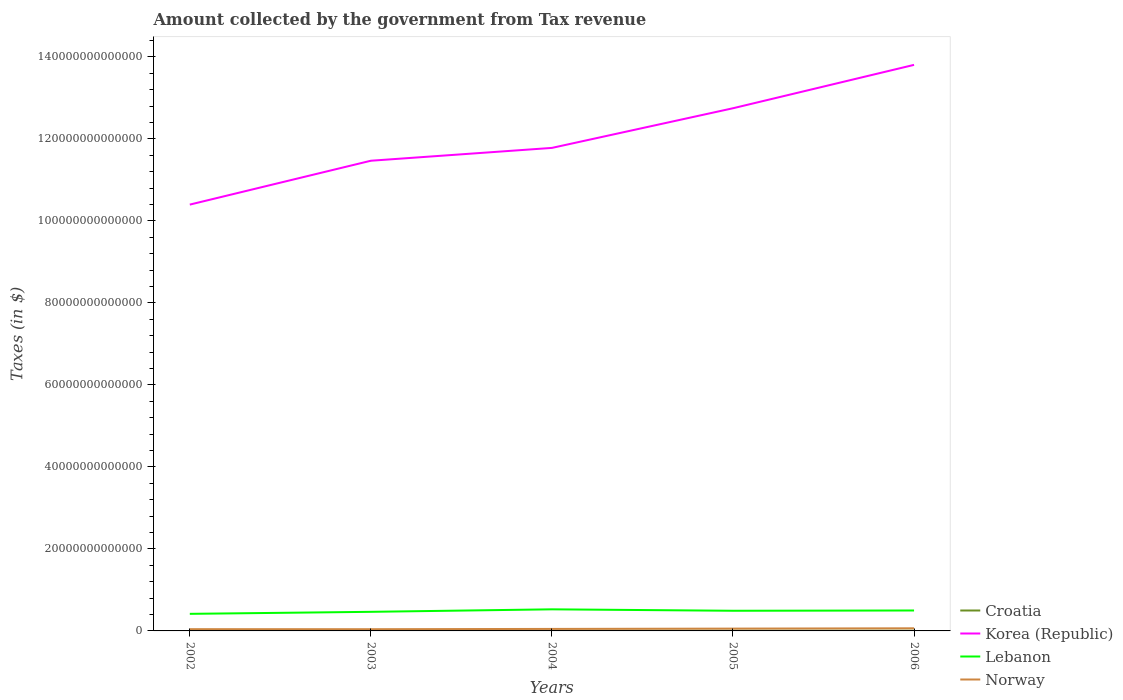Across all years, what is the maximum amount collected by the government from tax revenue in Lebanon?
Keep it short and to the point. 4.17e+12. In which year was the amount collected by the government from tax revenue in Croatia maximum?
Provide a succinct answer. 2002. What is the total amount collected by the government from tax revenue in Korea (Republic) in the graph?
Provide a short and direct response. -1.38e+13. What is the difference between the highest and the second highest amount collected by the government from tax revenue in Lebanon?
Your answer should be very brief. 1.10e+12. Is the amount collected by the government from tax revenue in Lebanon strictly greater than the amount collected by the government from tax revenue in Croatia over the years?
Offer a very short reply. No. How many years are there in the graph?
Your answer should be very brief. 5. What is the difference between two consecutive major ticks on the Y-axis?
Provide a short and direct response. 2.00e+13. Are the values on the major ticks of Y-axis written in scientific E-notation?
Your answer should be very brief. No. Does the graph contain grids?
Make the answer very short. No. Where does the legend appear in the graph?
Offer a terse response. Bottom right. How many legend labels are there?
Offer a terse response. 4. How are the legend labels stacked?
Provide a succinct answer. Vertical. What is the title of the graph?
Provide a succinct answer. Amount collected by the government from Tax revenue. What is the label or title of the Y-axis?
Keep it short and to the point. Taxes (in $). What is the Taxes (in $) in Croatia in 2002?
Your response must be concise. 4.52e+1. What is the Taxes (in $) in Korea (Republic) in 2002?
Provide a short and direct response. 1.04e+14. What is the Taxes (in $) of Lebanon in 2002?
Ensure brevity in your answer.  4.17e+12. What is the Taxes (in $) in Norway in 2002?
Ensure brevity in your answer.  4.28e+11. What is the Taxes (in $) of Croatia in 2003?
Your answer should be very brief. 4.79e+1. What is the Taxes (in $) in Korea (Republic) in 2003?
Offer a terse response. 1.15e+14. What is the Taxes (in $) in Lebanon in 2003?
Offer a terse response. 4.66e+12. What is the Taxes (in $) in Norway in 2003?
Your response must be concise. 4.19e+11. What is the Taxes (in $) of Croatia in 2004?
Ensure brevity in your answer.  4.98e+1. What is the Taxes (in $) of Korea (Republic) in 2004?
Give a very brief answer. 1.18e+14. What is the Taxes (in $) of Lebanon in 2004?
Your response must be concise. 5.27e+12. What is the Taxes (in $) of Norway in 2004?
Your answer should be compact. 4.87e+11. What is the Taxes (in $) in Croatia in 2005?
Your answer should be compact. 5.34e+1. What is the Taxes (in $) of Korea (Republic) in 2005?
Provide a succinct answer. 1.27e+14. What is the Taxes (in $) in Lebanon in 2005?
Ensure brevity in your answer.  4.92e+12. What is the Taxes (in $) in Norway in 2005?
Provide a short and direct response. 5.63e+11. What is the Taxes (in $) of Croatia in 2006?
Your response must be concise. 5.85e+1. What is the Taxes (in $) in Korea (Republic) in 2006?
Keep it short and to the point. 1.38e+14. What is the Taxes (in $) of Lebanon in 2006?
Ensure brevity in your answer.  4.98e+12. What is the Taxes (in $) of Norway in 2006?
Provide a succinct answer. 6.41e+11. Across all years, what is the maximum Taxes (in $) of Croatia?
Give a very brief answer. 5.85e+1. Across all years, what is the maximum Taxes (in $) of Korea (Republic)?
Ensure brevity in your answer.  1.38e+14. Across all years, what is the maximum Taxes (in $) of Lebanon?
Provide a short and direct response. 5.27e+12. Across all years, what is the maximum Taxes (in $) in Norway?
Offer a terse response. 6.41e+11. Across all years, what is the minimum Taxes (in $) of Croatia?
Offer a terse response. 4.52e+1. Across all years, what is the minimum Taxes (in $) in Korea (Republic)?
Give a very brief answer. 1.04e+14. Across all years, what is the minimum Taxes (in $) of Lebanon?
Your response must be concise. 4.17e+12. Across all years, what is the minimum Taxes (in $) of Norway?
Give a very brief answer. 4.19e+11. What is the total Taxes (in $) of Croatia in the graph?
Give a very brief answer. 2.55e+11. What is the total Taxes (in $) of Korea (Republic) in the graph?
Make the answer very short. 6.02e+14. What is the total Taxes (in $) in Lebanon in the graph?
Give a very brief answer. 2.40e+13. What is the total Taxes (in $) in Norway in the graph?
Your answer should be compact. 2.54e+12. What is the difference between the Taxes (in $) of Croatia in 2002 and that in 2003?
Keep it short and to the point. -2.74e+09. What is the difference between the Taxes (in $) of Korea (Republic) in 2002 and that in 2003?
Provide a succinct answer. -1.07e+13. What is the difference between the Taxes (in $) in Lebanon in 2002 and that in 2003?
Make the answer very short. -4.89e+11. What is the difference between the Taxes (in $) of Norway in 2002 and that in 2003?
Offer a very short reply. 9.12e+09. What is the difference between the Taxes (in $) in Croatia in 2002 and that in 2004?
Give a very brief answer. -4.66e+09. What is the difference between the Taxes (in $) of Korea (Republic) in 2002 and that in 2004?
Keep it short and to the point. -1.38e+13. What is the difference between the Taxes (in $) of Lebanon in 2002 and that in 2004?
Offer a terse response. -1.10e+12. What is the difference between the Taxes (in $) in Norway in 2002 and that in 2004?
Give a very brief answer. -5.94e+1. What is the difference between the Taxes (in $) in Croatia in 2002 and that in 2005?
Give a very brief answer. -8.28e+09. What is the difference between the Taxes (in $) of Korea (Republic) in 2002 and that in 2005?
Offer a terse response. -2.35e+13. What is the difference between the Taxes (in $) in Lebanon in 2002 and that in 2005?
Make the answer very short. -7.49e+11. What is the difference between the Taxes (in $) in Norway in 2002 and that in 2005?
Your answer should be very brief. -1.35e+11. What is the difference between the Taxes (in $) in Croatia in 2002 and that in 2006?
Provide a short and direct response. -1.33e+1. What is the difference between the Taxes (in $) of Korea (Republic) in 2002 and that in 2006?
Give a very brief answer. -3.41e+13. What is the difference between the Taxes (in $) of Lebanon in 2002 and that in 2006?
Keep it short and to the point. -8.16e+11. What is the difference between the Taxes (in $) of Norway in 2002 and that in 2006?
Give a very brief answer. -2.13e+11. What is the difference between the Taxes (in $) in Croatia in 2003 and that in 2004?
Keep it short and to the point. -1.92e+09. What is the difference between the Taxes (in $) in Korea (Republic) in 2003 and that in 2004?
Your answer should be compact. -3.13e+12. What is the difference between the Taxes (in $) in Lebanon in 2003 and that in 2004?
Keep it short and to the point. -6.11e+11. What is the difference between the Taxes (in $) of Norway in 2003 and that in 2004?
Give a very brief answer. -6.85e+1. What is the difference between the Taxes (in $) of Croatia in 2003 and that in 2005?
Keep it short and to the point. -5.54e+09. What is the difference between the Taxes (in $) in Korea (Republic) in 2003 and that in 2005?
Your answer should be compact. -1.28e+13. What is the difference between the Taxes (in $) of Lebanon in 2003 and that in 2005?
Ensure brevity in your answer.  -2.60e+11. What is the difference between the Taxes (in $) in Norway in 2003 and that in 2005?
Offer a terse response. -1.44e+11. What is the difference between the Taxes (in $) of Croatia in 2003 and that in 2006?
Make the answer very short. -1.06e+1. What is the difference between the Taxes (in $) in Korea (Republic) in 2003 and that in 2006?
Give a very brief answer. -2.34e+13. What is the difference between the Taxes (in $) of Lebanon in 2003 and that in 2006?
Keep it short and to the point. -3.27e+11. What is the difference between the Taxes (in $) of Norway in 2003 and that in 2006?
Give a very brief answer. -2.22e+11. What is the difference between the Taxes (in $) of Croatia in 2004 and that in 2005?
Provide a short and direct response. -3.62e+09. What is the difference between the Taxes (in $) of Korea (Republic) in 2004 and that in 2005?
Offer a very short reply. -9.67e+12. What is the difference between the Taxes (in $) of Lebanon in 2004 and that in 2005?
Your answer should be very brief. 3.50e+11. What is the difference between the Taxes (in $) of Norway in 2004 and that in 2005?
Your answer should be compact. -7.53e+1. What is the difference between the Taxes (in $) in Croatia in 2004 and that in 2006?
Keep it short and to the point. -8.64e+09. What is the difference between the Taxes (in $) of Korea (Republic) in 2004 and that in 2006?
Keep it short and to the point. -2.02e+13. What is the difference between the Taxes (in $) of Lebanon in 2004 and that in 2006?
Your answer should be compact. 2.83e+11. What is the difference between the Taxes (in $) in Norway in 2004 and that in 2006?
Your answer should be compact. -1.54e+11. What is the difference between the Taxes (in $) in Croatia in 2005 and that in 2006?
Offer a very short reply. -5.02e+09. What is the difference between the Taxes (in $) of Korea (Republic) in 2005 and that in 2006?
Offer a terse response. -1.06e+13. What is the difference between the Taxes (in $) of Lebanon in 2005 and that in 2006?
Ensure brevity in your answer.  -6.71e+1. What is the difference between the Taxes (in $) in Norway in 2005 and that in 2006?
Offer a terse response. -7.84e+1. What is the difference between the Taxes (in $) of Croatia in 2002 and the Taxes (in $) of Korea (Republic) in 2003?
Give a very brief answer. -1.15e+14. What is the difference between the Taxes (in $) in Croatia in 2002 and the Taxes (in $) in Lebanon in 2003?
Keep it short and to the point. -4.61e+12. What is the difference between the Taxes (in $) of Croatia in 2002 and the Taxes (in $) of Norway in 2003?
Offer a very short reply. -3.74e+11. What is the difference between the Taxes (in $) of Korea (Republic) in 2002 and the Taxes (in $) of Lebanon in 2003?
Provide a short and direct response. 9.93e+13. What is the difference between the Taxes (in $) in Korea (Republic) in 2002 and the Taxes (in $) in Norway in 2003?
Your response must be concise. 1.04e+14. What is the difference between the Taxes (in $) in Lebanon in 2002 and the Taxes (in $) in Norway in 2003?
Give a very brief answer. 3.75e+12. What is the difference between the Taxes (in $) in Croatia in 2002 and the Taxes (in $) in Korea (Republic) in 2004?
Keep it short and to the point. -1.18e+14. What is the difference between the Taxes (in $) in Croatia in 2002 and the Taxes (in $) in Lebanon in 2004?
Ensure brevity in your answer.  -5.22e+12. What is the difference between the Taxes (in $) in Croatia in 2002 and the Taxes (in $) in Norway in 2004?
Offer a very short reply. -4.42e+11. What is the difference between the Taxes (in $) in Korea (Republic) in 2002 and the Taxes (in $) in Lebanon in 2004?
Offer a very short reply. 9.87e+13. What is the difference between the Taxes (in $) of Korea (Republic) in 2002 and the Taxes (in $) of Norway in 2004?
Keep it short and to the point. 1.03e+14. What is the difference between the Taxes (in $) of Lebanon in 2002 and the Taxes (in $) of Norway in 2004?
Keep it short and to the point. 3.68e+12. What is the difference between the Taxes (in $) of Croatia in 2002 and the Taxes (in $) of Korea (Republic) in 2005?
Provide a succinct answer. -1.27e+14. What is the difference between the Taxes (in $) in Croatia in 2002 and the Taxes (in $) in Lebanon in 2005?
Offer a terse response. -4.87e+12. What is the difference between the Taxes (in $) of Croatia in 2002 and the Taxes (in $) of Norway in 2005?
Offer a terse response. -5.18e+11. What is the difference between the Taxes (in $) in Korea (Republic) in 2002 and the Taxes (in $) in Lebanon in 2005?
Ensure brevity in your answer.  9.91e+13. What is the difference between the Taxes (in $) of Korea (Republic) in 2002 and the Taxes (in $) of Norway in 2005?
Your answer should be very brief. 1.03e+14. What is the difference between the Taxes (in $) in Lebanon in 2002 and the Taxes (in $) in Norway in 2005?
Your response must be concise. 3.60e+12. What is the difference between the Taxes (in $) in Croatia in 2002 and the Taxes (in $) in Korea (Republic) in 2006?
Offer a terse response. -1.38e+14. What is the difference between the Taxes (in $) of Croatia in 2002 and the Taxes (in $) of Lebanon in 2006?
Offer a very short reply. -4.94e+12. What is the difference between the Taxes (in $) in Croatia in 2002 and the Taxes (in $) in Norway in 2006?
Your response must be concise. -5.96e+11. What is the difference between the Taxes (in $) in Korea (Republic) in 2002 and the Taxes (in $) in Lebanon in 2006?
Ensure brevity in your answer.  9.90e+13. What is the difference between the Taxes (in $) of Korea (Republic) in 2002 and the Taxes (in $) of Norway in 2006?
Make the answer very short. 1.03e+14. What is the difference between the Taxes (in $) in Lebanon in 2002 and the Taxes (in $) in Norway in 2006?
Offer a terse response. 3.53e+12. What is the difference between the Taxes (in $) of Croatia in 2003 and the Taxes (in $) of Korea (Republic) in 2004?
Your response must be concise. -1.18e+14. What is the difference between the Taxes (in $) in Croatia in 2003 and the Taxes (in $) in Lebanon in 2004?
Keep it short and to the point. -5.22e+12. What is the difference between the Taxes (in $) in Croatia in 2003 and the Taxes (in $) in Norway in 2004?
Provide a succinct answer. -4.39e+11. What is the difference between the Taxes (in $) in Korea (Republic) in 2003 and the Taxes (in $) in Lebanon in 2004?
Ensure brevity in your answer.  1.09e+14. What is the difference between the Taxes (in $) in Korea (Republic) in 2003 and the Taxes (in $) in Norway in 2004?
Provide a succinct answer. 1.14e+14. What is the difference between the Taxes (in $) in Lebanon in 2003 and the Taxes (in $) in Norway in 2004?
Your answer should be compact. 4.17e+12. What is the difference between the Taxes (in $) of Croatia in 2003 and the Taxes (in $) of Korea (Republic) in 2005?
Your response must be concise. -1.27e+14. What is the difference between the Taxes (in $) of Croatia in 2003 and the Taxes (in $) of Lebanon in 2005?
Ensure brevity in your answer.  -4.87e+12. What is the difference between the Taxes (in $) in Croatia in 2003 and the Taxes (in $) in Norway in 2005?
Your answer should be very brief. -5.15e+11. What is the difference between the Taxes (in $) of Korea (Republic) in 2003 and the Taxes (in $) of Lebanon in 2005?
Provide a succinct answer. 1.10e+14. What is the difference between the Taxes (in $) in Korea (Republic) in 2003 and the Taxes (in $) in Norway in 2005?
Provide a short and direct response. 1.14e+14. What is the difference between the Taxes (in $) in Lebanon in 2003 and the Taxes (in $) in Norway in 2005?
Provide a succinct answer. 4.09e+12. What is the difference between the Taxes (in $) of Croatia in 2003 and the Taxes (in $) of Korea (Republic) in 2006?
Your answer should be compact. -1.38e+14. What is the difference between the Taxes (in $) of Croatia in 2003 and the Taxes (in $) of Lebanon in 2006?
Provide a short and direct response. -4.93e+12. What is the difference between the Taxes (in $) in Croatia in 2003 and the Taxes (in $) in Norway in 2006?
Your answer should be very brief. -5.93e+11. What is the difference between the Taxes (in $) in Korea (Republic) in 2003 and the Taxes (in $) in Lebanon in 2006?
Give a very brief answer. 1.10e+14. What is the difference between the Taxes (in $) of Korea (Republic) in 2003 and the Taxes (in $) of Norway in 2006?
Offer a terse response. 1.14e+14. What is the difference between the Taxes (in $) in Lebanon in 2003 and the Taxes (in $) in Norway in 2006?
Provide a succinct answer. 4.01e+12. What is the difference between the Taxes (in $) in Croatia in 2004 and the Taxes (in $) in Korea (Republic) in 2005?
Provide a short and direct response. -1.27e+14. What is the difference between the Taxes (in $) in Croatia in 2004 and the Taxes (in $) in Lebanon in 2005?
Keep it short and to the point. -4.87e+12. What is the difference between the Taxes (in $) in Croatia in 2004 and the Taxes (in $) in Norway in 2005?
Your answer should be compact. -5.13e+11. What is the difference between the Taxes (in $) in Korea (Republic) in 2004 and the Taxes (in $) in Lebanon in 2005?
Provide a succinct answer. 1.13e+14. What is the difference between the Taxes (in $) of Korea (Republic) in 2004 and the Taxes (in $) of Norway in 2005?
Make the answer very short. 1.17e+14. What is the difference between the Taxes (in $) of Lebanon in 2004 and the Taxes (in $) of Norway in 2005?
Offer a very short reply. 4.70e+12. What is the difference between the Taxes (in $) of Croatia in 2004 and the Taxes (in $) of Korea (Republic) in 2006?
Your answer should be very brief. -1.38e+14. What is the difference between the Taxes (in $) of Croatia in 2004 and the Taxes (in $) of Lebanon in 2006?
Your answer should be very brief. -4.93e+12. What is the difference between the Taxes (in $) of Croatia in 2004 and the Taxes (in $) of Norway in 2006?
Provide a short and direct response. -5.91e+11. What is the difference between the Taxes (in $) of Korea (Republic) in 2004 and the Taxes (in $) of Lebanon in 2006?
Offer a very short reply. 1.13e+14. What is the difference between the Taxes (in $) of Korea (Republic) in 2004 and the Taxes (in $) of Norway in 2006?
Your response must be concise. 1.17e+14. What is the difference between the Taxes (in $) in Lebanon in 2004 and the Taxes (in $) in Norway in 2006?
Give a very brief answer. 4.62e+12. What is the difference between the Taxes (in $) in Croatia in 2005 and the Taxes (in $) in Korea (Republic) in 2006?
Provide a short and direct response. -1.38e+14. What is the difference between the Taxes (in $) of Croatia in 2005 and the Taxes (in $) of Lebanon in 2006?
Make the answer very short. -4.93e+12. What is the difference between the Taxes (in $) of Croatia in 2005 and the Taxes (in $) of Norway in 2006?
Your answer should be compact. -5.88e+11. What is the difference between the Taxes (in $) of Korea (Republic) in 2005 and the Taxes (in $) of Lebanon in 2006?
Your answer should be very brief. 1.22e+14. What is the difference between the Taxes (in $) of Korea (Republic) in 2005 and the Taxes (in $) of Norway in 2006?
Your answer should be very brief. 1.27e+14. What is the difference between the Taxes (in $) of Lebanon in 2005 and the Taxes (in $) of Norway in 2006?
Provide a short and direct response. 4.27e+12. What is the average Taxes (in $) in Croatia per year?
Ensure brevity in your answer.  5.10e+1. What is the average Taxes (in $) of Korea (Republic) per year?
Provide a succinct answer. 1.20e+14. What is the average Taxes (in $) in Lebanon per year?
Your answer should be compact. 4.80e+12. What is the average Taxes (in $) in Norway per year?
Offer a very short reply. 5.08e+11. In the year 2002, what is the difference between the Taxes (in $) of Croatia and Taxes (in $) of Korea (Republic)?
Your response must be concise. -1.04e+14. In the year 2002, what is the difference between the Taxes (in $) of Croatia and Taxes (in $) of Lebanon?
Keep it short and to the point. -4.12e+12. In the year 2002, what is the difference between the Taxes (in $) in Croatia and Taxes (in $) in Norway?
Ensure brevity in your answer.  -3.83e+11. In the year 2002, what is the difference between the Taxes (in $) in Korea (Republic) and Taxes (in $) in Lebanon?
Your answer should be compact. 9.98e+13. In the year 2002, what is the difference between the Taxes (in $) in Korea (Republic) and Taxes (in $) in Norway?
Your response must be concise. 1.04e+14. In the year 2002, what is the difference between the Taxes (in $) of Lebanon and Taxes (in $) of Norway?
Your response must be concise. 3.74e+12. In the year 2003, what is the difference between the Taxes (in $) of Croatia and Taxes (in $) of Korea (Republic)?
Offer a very short reply. -1.15e+14. In the year 2003, what is the difference between the Taxes (in $) in Croatia and Taxes (in $) in Lebanon?
Ensure brevity in your answer.  -4.61e+12. In the year 2003, what is the difference between the Taxes (in $) of Croatia and Taxes (in $) of Norway?
Offer a very short reply. -3.71e+11. In the year 2003, what is the difference between the Taxes (in $) of Korea (Republic) and Taxes (in $) of Lebanon?
Your response must be concise. 1.10e+14. In the year 2003, what is the difference between the Taxes (in $) in Korea (Republic) and Taxes (in $) in Norway?
Keep it short and to the point. 1.14e+14. In the year 2003, what is the difference between the Taxes (in $) of Lebanon and Taxes (in $) of Norway?
Your answer should be compact. 4.24e+12. In the year 2004, what is the difference between the Taxes (in $) in Croatia and Taxes (in $) in Korea (Republic)?
Ensure brevity in your answer.  -1.18e+14. In the year 2004, what is the difference between the Taxes (in $) of Croatia and Taxes (in $) of Lebanon?
Keep it short and to the point. -5.22e+12. In the year 2004, what is the difference between the Taxes (in $) in Croatia and Taxes (in $) in Norway?
Your answer should be very brief. -4.38e+11. In the year 2004, what is the difference between the Taxes (in $) in Korea (Republic) and Taxes (in $) in Lebanon?
Provide a succinct answer. 1.13e+14. In the year 2004, what is the difference between the Taxes (in $) in Korea (Republic) and Taxes (in $) in Norway?
Provide a succinct answer. 1.17e+14. In the year 2004, what is the difference between the Taxes (in $) in Lebanon and Taxes (in $) in Norway?
Offer a terse response. 4.78e+12. In the year 2005, what is the difference between the Taxes (in $) of Croatia and Taxes (in $) of Korea (Republic)?
Ensure brevity in your answer.  -1.27e+14. In the year 2005, what is the difference between the Taxes (in $) of Croatia and Taxes (in $) of Lebanon?
Your answer should be very brief. -4.86e+12. In the year 2005, what is the difference between the Taxes (in $) in Croatia and Taxes (in $) in Norway?
Keep it short and to the point. -5.09e+11. In the year 2005, what is the difference between the Taxes (in $) in Korea (Republic) and Taxes (in $) in Lebanon?
Offer a very short reply. 1.23e+14. In the year 2005, what is the difference between the Taxes (in $) of Korea (Republic) and Taxes (in $) of Norway?
Your answer should be compact. 1.27e+14. In the year 2005, what is the difference between the Taxes (in $) of Lebanon and Taxes (in $) of Norway?
Keep it short and to the point. 4.35e+12. In the year 2006, what is the difference between the Taxes (in $) of Croatia and Taxes (in $) of Korea (Republic)?
Your response must be concise. -1.38e+14. In the year 2006, what is the difference between the Taxes (in $) in Croatia and Taxes (in $) in Lebanon?
Give a very brief answer. -4.92e+12. In the year 2006, what is the difference between the Taxes (in $) in Croatia and Taxes (in $) in Norway?
Your answer should be compact. -5.83e+11. In the year 2006, what is the difference between the Taxes (in $) of Korea (Republic) and Taxes (in $) of Lebanon?
Ensure brevity in your answer.  1.33e+14. In the year 2006, what is the difference between the Taxes (in $) of Korea (Republic) and Taxes (in $) of Norway?
Provide a succinct answer. 1.37e+14. In the year 2006, what is the difference between the Taxes (in $) of Lebanon and Taxes (in $) of Norway?
Make the answer very short. 4.34e+12. What is the ratio of the Taxes (in $) in Croatia in 2002 to that in 2003?
Ensure brevity in your answer.  0.94. What is the ratio of the Taxes (in $) in Korea (Republic) in 2002 to that in 2003?
Ensure brevity in your answer.  0.91. What is the ratio of the Taxes (in $) of Lebanon in 2002 to that in 2003?
Your answer should be compact. 0.9. What is the ratio of the Taxes (in $) in Norway in 2002 to that in 2003?
Give a very brief answer. 1.02. What is the ratio of the Taxes (in $) in Croatia in 2002 to that in 2004?
Make the answer very short. 0.91. What is the ratio of the Taxes (in $) of Korea (Republic) in 2002 to that in 2004?
Your response must be concise. 0.88. What is the ratio of the Taxes (in $) in Lebanon in 2002 to that in 2004?
Ensure brevity in your answer.  0.79. What is the ratio of the Taxes (in $) of Norway in 2002 to that in 2004?
Make the answer very short. 0.88. What is the ratio of the Taxes (in $) of Croatia in 2002 to that in 2005?
Your answer should be very brief. 0.85. What is the ratio of the Taxes (in $) in Korea (Republic) in 2002 to that in 2005?
Offer a terse response. 0.82. What is the ratio of the Taxes (in $) in Lebanon in 2002 to that in 2005?
Ensure brevity in your answer.  0.85. What is the ratio of the Taxes (in $) in Norway in 2002 to that in 2005?
Your answer should be compact. 0.76. What is the ratio of the Taxes (in $) in Croatia in 2002 to that in 2006?
Provide a succinct answer. 0.77. What is the ratio of the Taxes (in $) in Korea (Republic) in 2002 to that in 2006?
Provide a succinct answer. 0.75. What is the ratio of the Taxes (in $) of Lebanon in 2002 to that in 2006?
Your answer should be compact. 0.84. What is the ratio of the Taxes (in $) of Norway in 2002 to that in 2006?
Make the answer very short. 0.67. What is the ratio of the Taxes (in $) of Croatia in 2003 to that in 2004?
Provide a succinct answer. 0.96. What is the ratio of the Taxes (in $) of Korea (Republic) in 2003 to that in 2004?
Offer a very short reply. 0.97. What is the ratio of the Taxes (in $) in Lebanon in 2003 to that in 2004?
Your response must be concise. 0.88. What is the ratio of the Taxes (in $) in Norway in 2003 to that in 2004?
Your answer should be very brief. 0.86. What is the ratio of the Taxes (in $) of Croatia in 2003 to that in 2005?
Your response must be concise. 0.9. What is the ratio of the Taxes (in $) in Korea (Republic) in 2003 to that in 2005?
Your response must be concise. 0.9. What is the ratio of the Taxes (in $) in Lebanon in 2003 to that in 2005?
Give a very brief answer. 0.95. What is the ratio of the Taxes (in $) of Norway in 2003 to that in 2005?
Ensure brevity in your answer.  0.74. What is the ratio of the Taxes (in $) in Croatia in 2003 to that in 2006?
Offer a very short reply. 0.82. What is the ratio of the Taxes (in $) of Korea (Republic) in 2003 to that in 2006?
Offer a terse response. 0.83. What is the ratio of the Taxes (in $) of Lebanon in 2003 to that in 2006?
Your answer should be very brief. 0.93. What is the ratio of the Taxes (in $) in Norway in 2003 to that in 2006?
Offer a very short reply. 0.65. What is the ratio of the Taxes (in $) of Croatia in 2004 to that in 2005?
Make the answer very short. 0.93. What is the ratio of the Taxes (in $) of Korea (Republic) in 2004 to that in 2005?
Offer a very short reply. 0.92. What is the ratio of the Taxes (in $) of Lebanon in 2004 to that in 2005?
Keep it short and to the point. 1.07. What is the ratio of the Taxes (in $) of Norway in 2004 to that in 2005?
Your answer should be very brief. 0.87. What is the ratio of the Taxes (in $) of Croatia in 2004 to that in 2006?
Make the answer very short. 0.85. What is the ratio of the Taxes (in $) in Korea (Republic) in 2004 to that in 2006?
Your answer should be very brief. 0.85. What is the ratio of the Taxes (in $) in Lebanon in 2004 to that in 2006?
Give a very brief answer. 1.06. What is the ratio of the Taxes (in $) in Norway in 2004 to that in 2006?
Make the answer very short. 0.76. What is the ratio of the Taxes (in $) in Croatia in 2005 to that in 2006?
Give a very brief answer. 0.91. What is the ratio of the Taxes (in $) in Korea (Republic) in 2005 to that in 2006?
Your answer should be compact. 0.92. What is the ratio of the Taxes (in $) of Lebanon in 2005 to that in 2006?
Your answer should be compact. 0.99. What is the ratio of the Taxes (in $) of Norway in 2005 to that in 2006?
Offer a very short reply. 0.88. What is the difference between the highest and the second highest Taxes (in $) in Croatia?
Give a very brief answer. 5.02e+09. What is the difference between the highest and the second highest Taxes (in $) of Korea (Republic)?
Your answer should be very brief. 1.06e+13. What is the difference between the highest and the second highest Taxes (in $) in Lebanon?
Provide a succinct answer. 2.83e+11. What is the difference between the highest and the second highest Taxes (in $) in Norway?
Provide a succinct answer. 7.84e+1. What is the difference between the highest and the lowest Taxes (in $) in Croatia?
Ensure brevity in your answer.  1.33e+1. What is the difference between the highest and the lowest Taxes (in $) in Korea (Republic)?
Provide a short and direct response. 3.41e+13. What is the difference between the highest and the lowest Taxes (in $) in Lebanon?
Offer a very short reply. 1.10e+12. What is the difference between the highest and the lowest Taxes (in $) in Norway?
Your answer should be compact. 2.22e+11. 